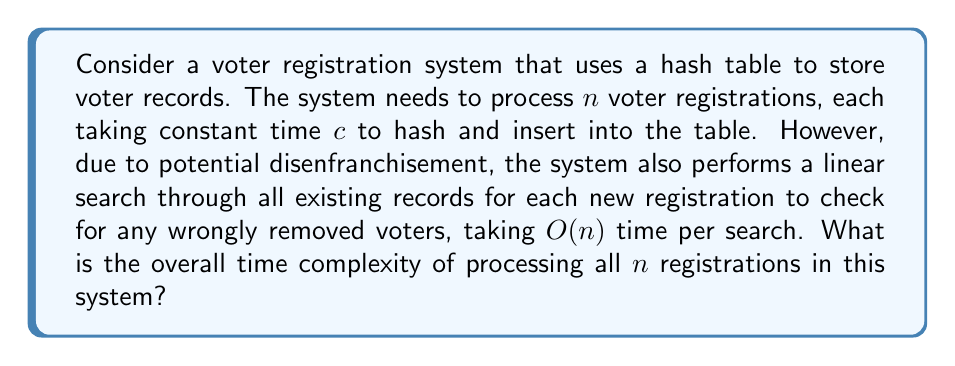Can you solve this math problem? Let's analyze this problem step by step:

1) For each voter registration:
   a) Hashing and insertion takes constant time $c$.
   b) Linear search through existing records takes $O(n)$ time.

2) We perform these operations $n$ times (once for each registration).

3) Let's express this mathematically:
   For the $i$-th registration $(1 \leq i \leq n)$:
   - Time for hashing and insertion: $c$
   - Time for linear search: $O(i-1)$ (as there are $i-1$ existing records)

4) Total time $T(n)$ can be expressed as:

   $$T(n) = \sum_{i=1}^n (c + O(i-1))$$

5) Simplifying:
   $$T(n) = \sum_{i=1}^n c + \sum_{i=1}^n O(i-1)$$
   $$T(n) = cn + O(\sum_{i=1}^n i)$$

6) We know that $\sum_{i=1}^n i = \frac{n(n+1)}{2}$

7) Therefore:
   $$T(n) = cn + O(\frac{n(n+1)}{2})$$
   $$T(n) = cn + O(n^2)$$

8) As $n$ grows large, the $O(n^2)$ term dominates, so we can simplify to:

   $$T(n) = O(n^2)$$

This quadratic time complexity reflects the system's inefficiency in repeatedly searching through all records, which could potentially delay the restoration of voting rights for unjustly disenfranchised voters.
Answer: $O(n^2)$ 